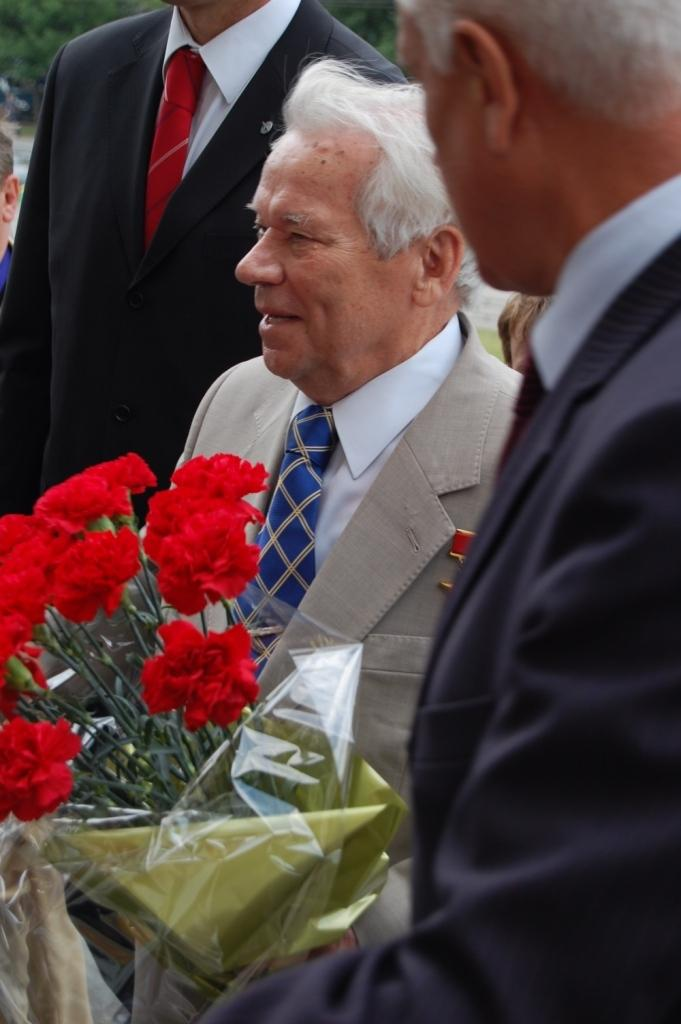Who is present in the image? There are people in the image. What are the people wearing? The people are wearing coats and ties. What is one of the people holding? One of the people is holding a bouquet. What can be seen in the background of the image? There are trees in the background of the image. What type of fruit is hanging from the trees in the background of the image? There is no fruit visible in the image, as the trees in the background do not have any fruit hanging from them. 